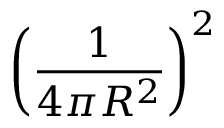Convert formula to latex. <formula><loc_0><loc_0><loc_500><loc_500>\left ( \frac { 1 } { 4 \pi R ^ { 2 } } \right ) ^ { 2 }</formula> 